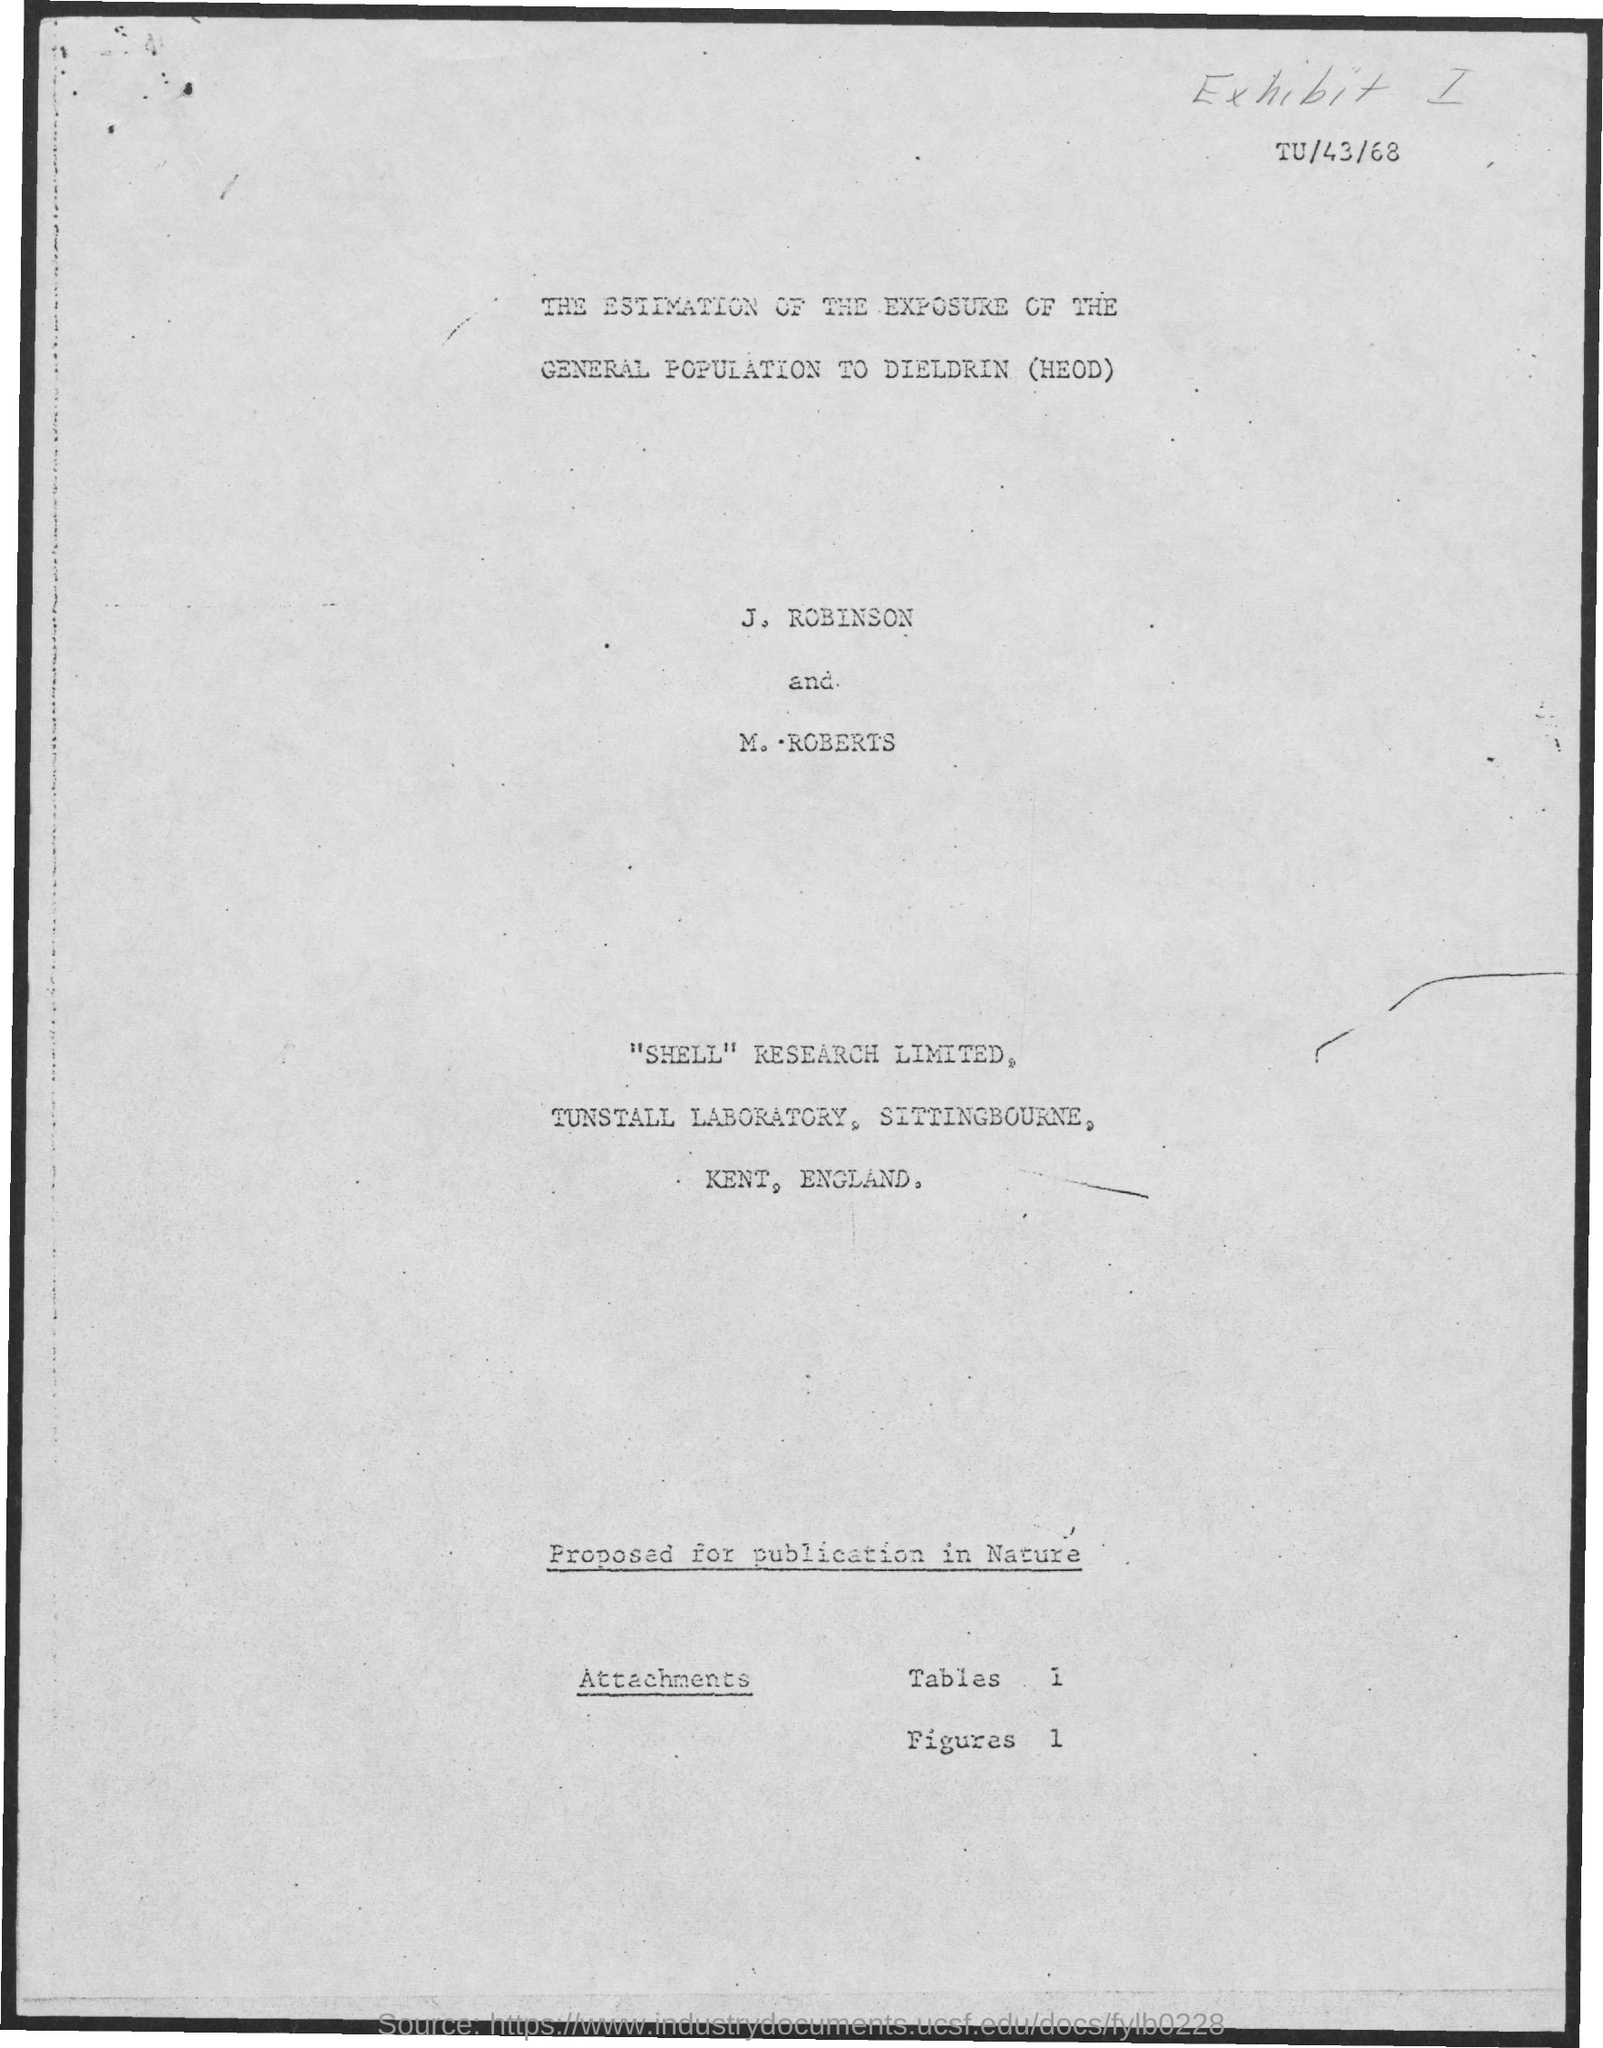What is the name of the two persons mentioned in the document?
Offer a very short reply. J. robinson and m. roberts. 